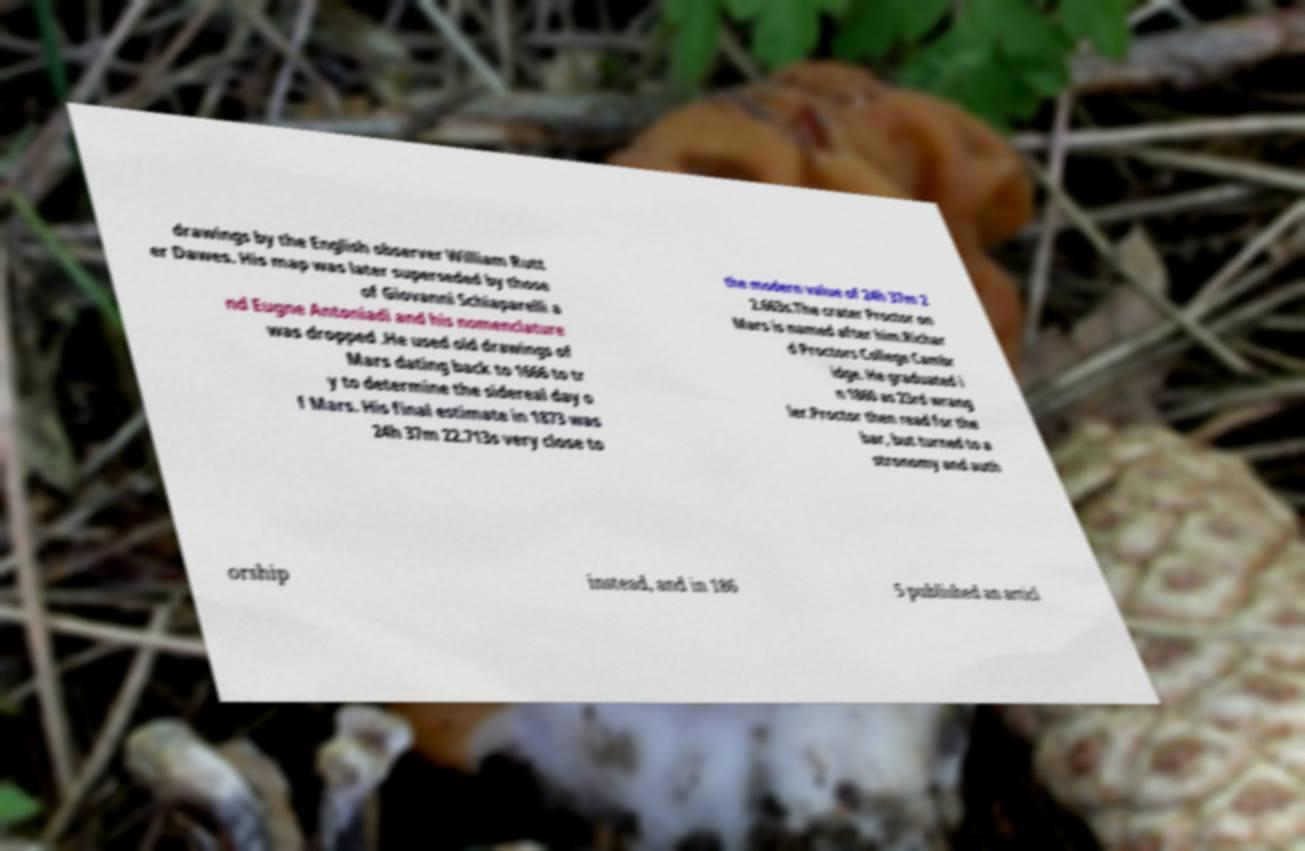Could you assist in decoding the text presented in this image and type it out clearly? drawings by the English observer William Rutt er Dawes. His map was later superseded by those of Giovanni Schiaparelli a nd Eugne Antoniadi and his nomenclature was dropped .He used old drawings of Mars dating back to 1666 to tr y to determine the sidereal day o f Mars. His final estimate in 1873 was 24h 37m 22.713s very close to the modern value of 24h 37m 2 2.663s.The crater Proctor on Mars is named after him.Richar d Proctors College Cambr idge. He graduated i n 1860 as 23rd wrang ler.Proctor then read for the bar, but turned to a stronomy and auth orship instead, and in 186 5 published an articl 